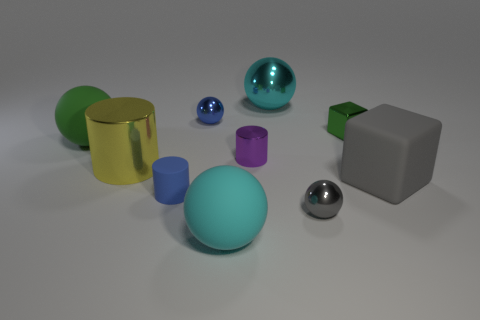Is the illumination source within the scene visible, or are there multiple sources of light? The lighting in the scene does not reveal a direct light source within the visible frame. Instead, the shadows and the diffuse light suggest ambient lighting, possibly from multiple sources that are out of view, illuminating the objects evenly, with soft shadows indicating a well-illuminated setting. 